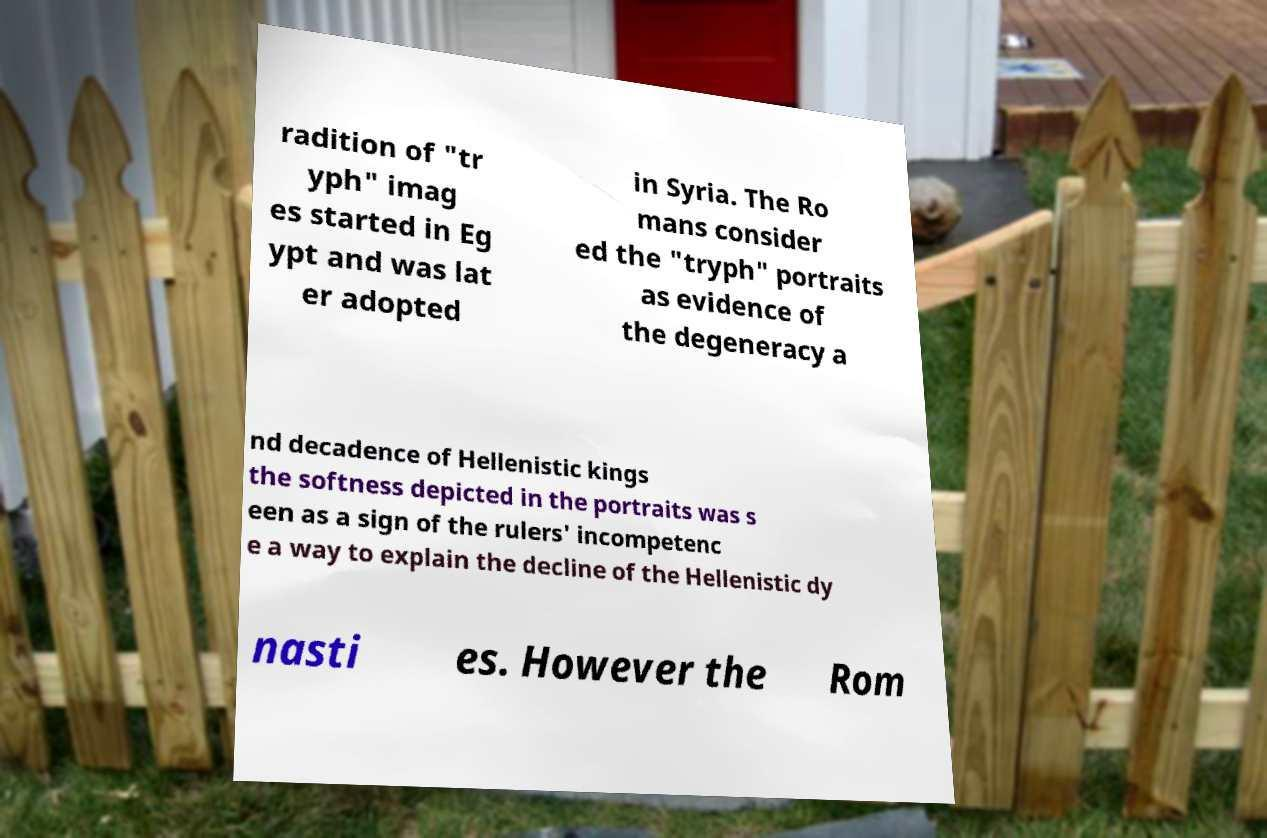There's text embedded in this image that I need extracted. Can you transcribe it verbatim? radition of "tr yph" imag es started in Eg ypt and was lat er adopted in Syria. The Ro mans consider ed the "tryph" portraits as evidence of the degeneracy a nd decadence of Hellenistic kings the softness depicted in the portraits was s een as a sign of the rulers' incompetenc e a way to explain the decline of the Hellenistic dy nasti es. However the Rom 